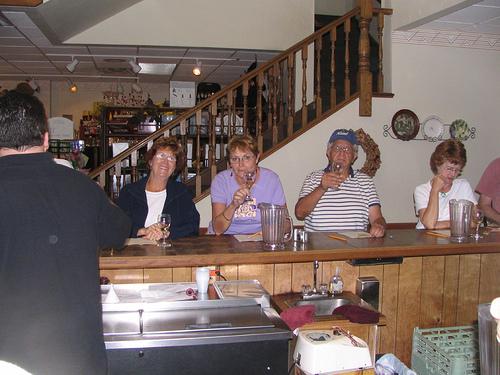What does the man have on his hand?
Keep it brief. Wine glass. How many people are in the photo?
Concise answer only. 6. What kind of venue is this?
Give a very brief answer. Bar. Are these chefs working?
Give a very brief answer. No. How many people are wearing hats?
Write a very short answer. 1. 